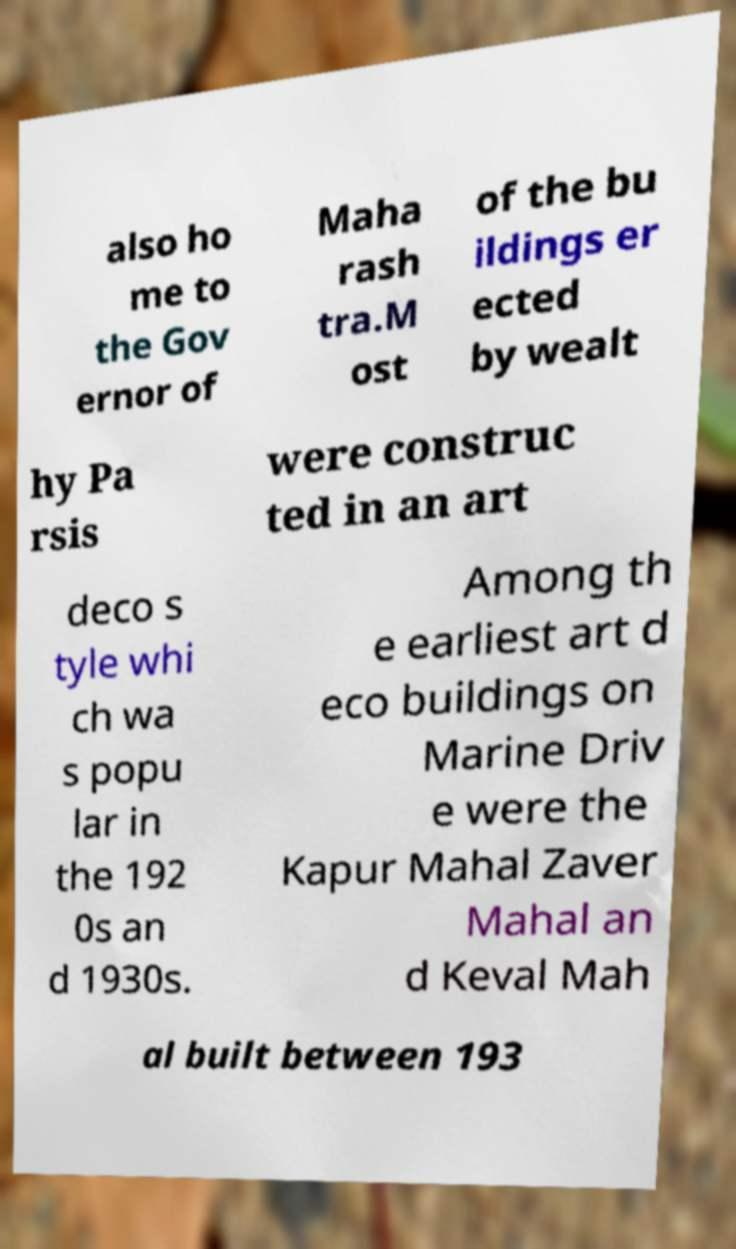There's text embedded in this image that I need extracted. Can you transcribe it verbatim? also ho me to the Gov ernor of Maha rash tra.M ost of the bu ildings er ected by wealt hy Pa rsis were construc ted in an art deco s tyle whi ch wa s popu lar in the 192 0s an d 1930s. Among th e earliest art d eco buildings on Marine Driv e were the Kapur Mahal Zaver Mahal an d Keval Mah al built between 193 